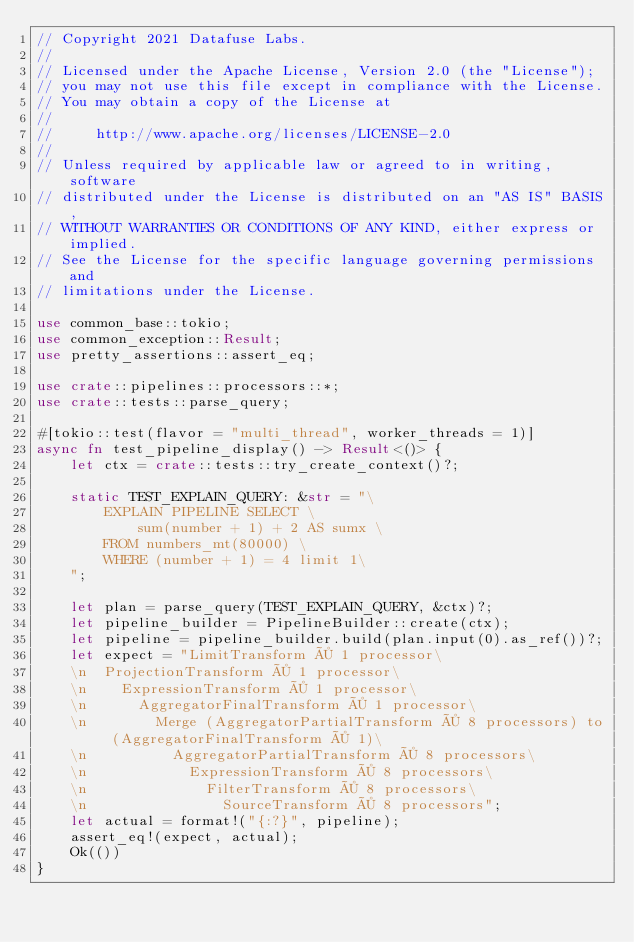Convert code to text. <code><loc_0><loc_0><loc_500><loc_500><_Rust_>// Copyright 2021 Datafuse Labs.
//
// Licensed under the Apache License, Version 2.0 (the "License");
// you may not use this file except in compliance with the License.
// You may obtain a copy of the License at
//
//     http://www.apache.org/licenses/LICENSE-2.0
//
// Unless required by applicable law or agreed to in writing, software
// distributed under the License is distributed on an "AS IS" BASIS,
// WITHOUT WARRANTIES OR CONDITIONS OF ANY KIND, either express or implied.
// See the License for the specific language governing permissions and
// limitations under the License.

use common_base::tokio;
use common_exception::Result;
use pretty_assertions::assert_eq;

use crate::pipelines::processors::*;
use crate::tests::parse_query;

#[tokio::test(flavor = "multi_thread", worker_threads = 1)]
async fn test_pipeline_display() -> Result<()> {
    let ctx = crate::tests::try_create_context()?;

    static TEST_EXPLAIN_QUERY: &str = "\
        EXPLAIN PIPELINE SELECT \
            sum(number + 1) + 2 AS sumx \
        FROM numbers_mt(80000) \
        WHERE (number + 1) = 4 limit 1\
    ";

    let plan = parse_query(TEST_EXPLAIN_QUERY, &ctx)?;
    let pipeline_builder = PipelineBuilder::create(ctx);
    let pipeline = pipeline_builder.build(plan.input(0).as_ref())?;
    let expect = "LimitTransform × 1 processor\
    \n  ProjectionTransform × 1 processor\
    \n    ExpressionTransform × 1 processor\
    \n      AggregatorFinalTransform × 1 processor\
    \n        Merge (AggregatorPartialTransform × 8 processors) to (AggregatorFinalTransform × 1)\
    \n          AggregatorPartialTransform × 8 processors\
    \n            ExpressionTransform × 8 processors\
    \n              FilterTransform × 8 processors\
    \n                SourceTransform × 8 processors";
    let actual = format!("{:?}", pipeline);
    assert_eq!(expect, actual);
    Ok(())
}
</code> 